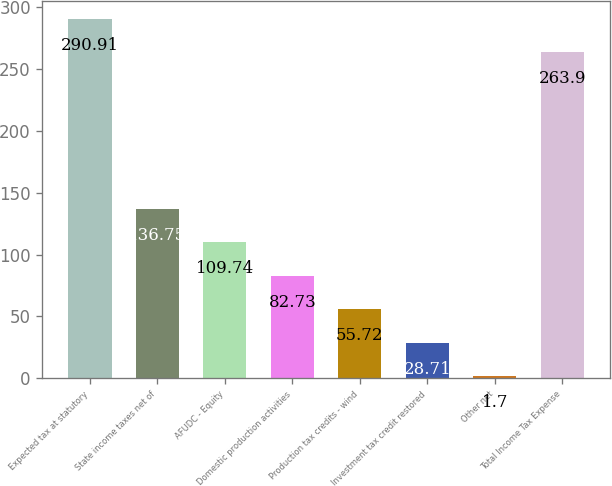<chart> <loc_0><loc_0><loc_500><loc_500><bar_chart><fcel>Expected tax at statutory<fcel>State income taxes net of<fcel>AFUDC - Equity<fcel>Domestic production activities<fcel>Production tax credits - wind<fcel>Investment tax credit restored<fcel>Other net<fcel>Total Income Tax Expense<nl><fcel>290.91<fcel>136.75<fcel>109.74<fcel>82.73<fcel>55.72<fcel>28.71<fcel>1.7<fcel>263.9<nl></chart> 